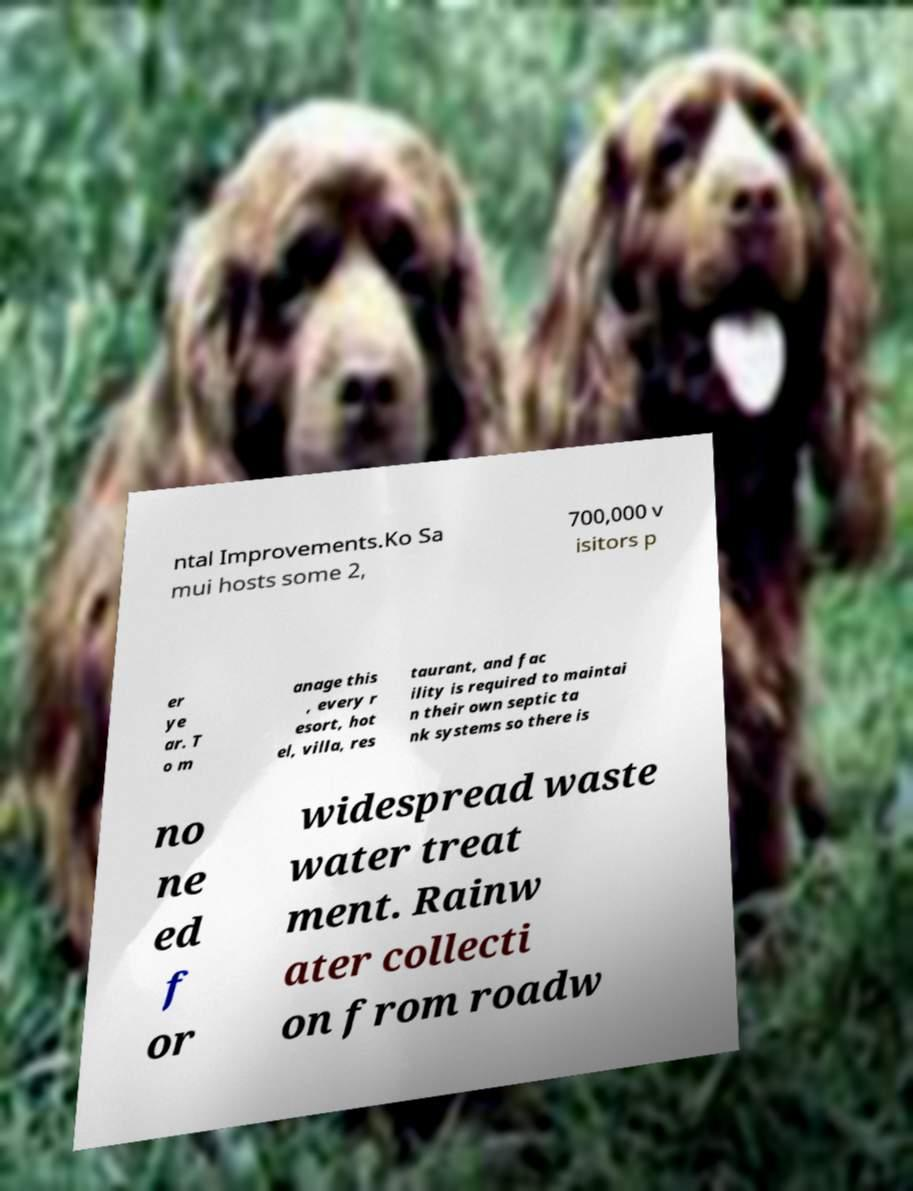What messages or text are displayed in this image? I need them in a readable, typed format. ntal Improvements.Ko Sa mui hosts some 2, 700,000 v isitors p er ye ar. T o m anage this , every r esort, hot el, villa, res taurant, and fac ility is required to maintai n their own septic ta nk systems so there is no ne ed f or widespread waste water treat ment. Rainw ater collecti on from roadw 